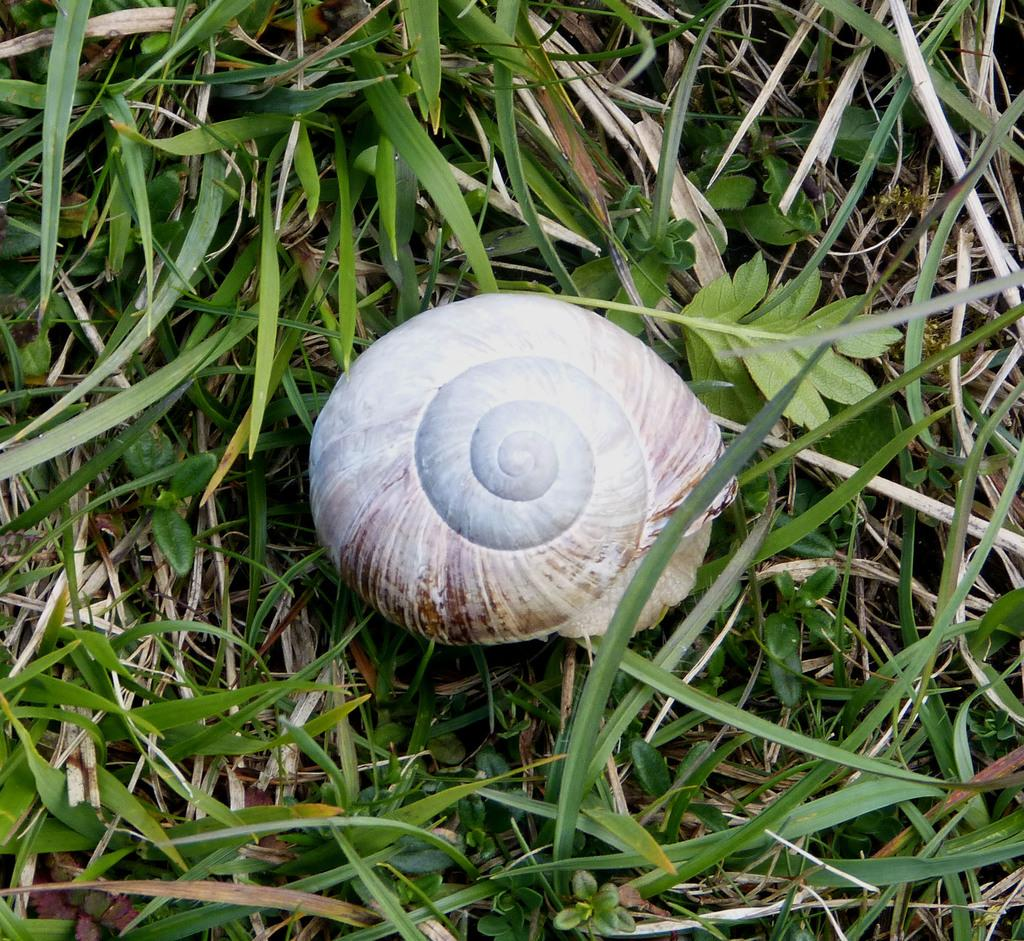What object can be seen in the image? There is a shell in the image. Where is the shell located? The shell is on the grass. How many passengers are visible in the image? There are no passengers present in the image; it only features a shell on the grass. What type of wine is being served in the image? There is no wine present in the image; it only features a shell on the grass. 